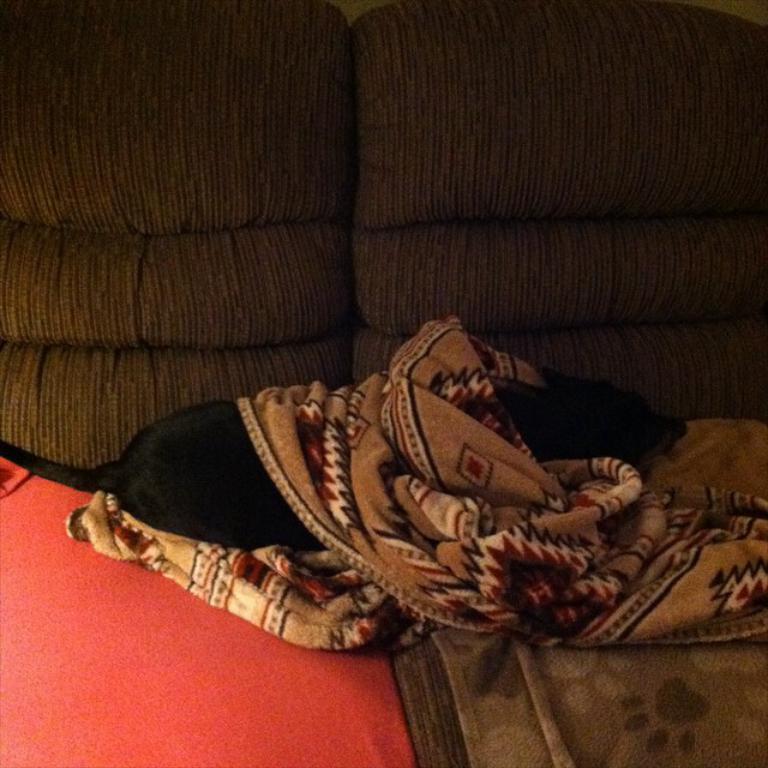Please provide a concise description of this image. In this image, we can see a dog lying on the sofa and we can see bed sheets. 